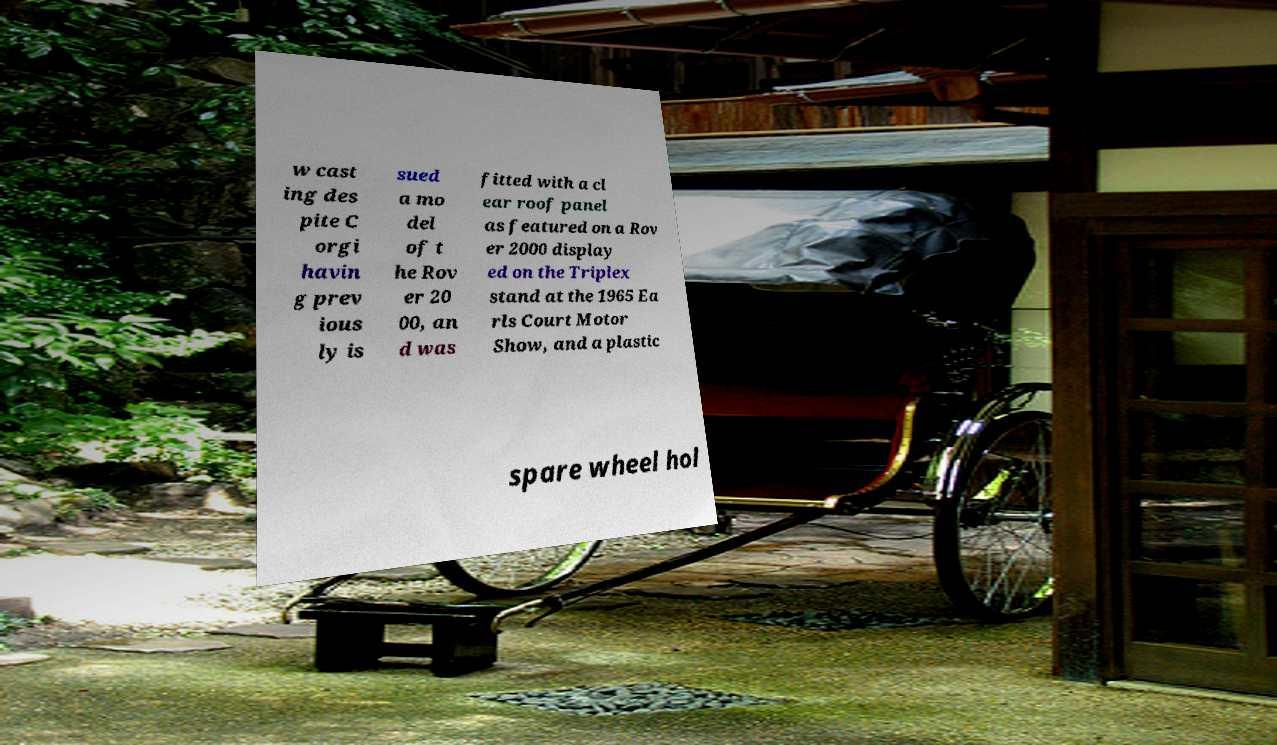Could you assist in decoding the text presented in this image and type it out clearly? w cast ing des pite C orgi havin g prev ious ly is sued a mo del of t he Rov er 20 00, an d was fitted with a cl ear roof panel as featured on a Rov er 2000 display ed on the Triplex stand at the 1965 Ea rls Court Motor Show, and a plastic spare wheel hol 